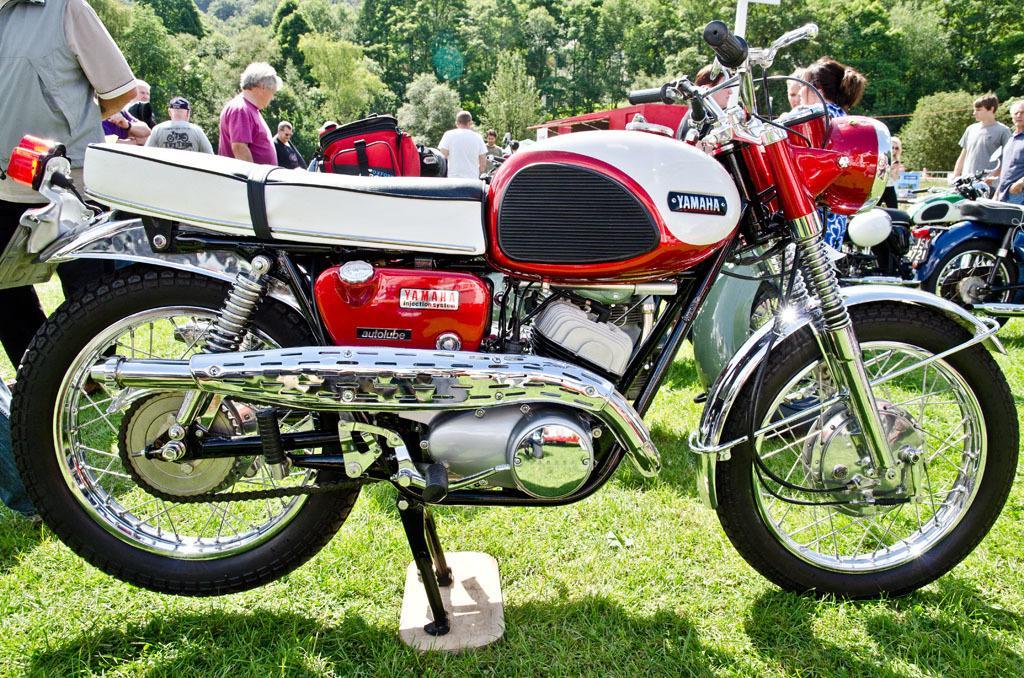Please provide a concise description of this image. In this image i can see a motorbike. In the background i can see few people and trees. 